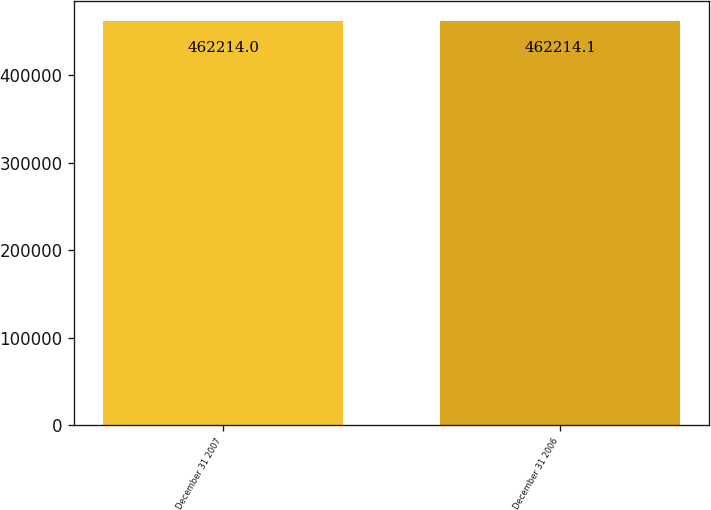Convert chart. <chart><loc_0><loc_0><loc_500><loc_500><bar_chart><fcel>December 31 2007<fcel>December 31 2006<nl><fcel>462214<fcel>462214<nl></chart> 